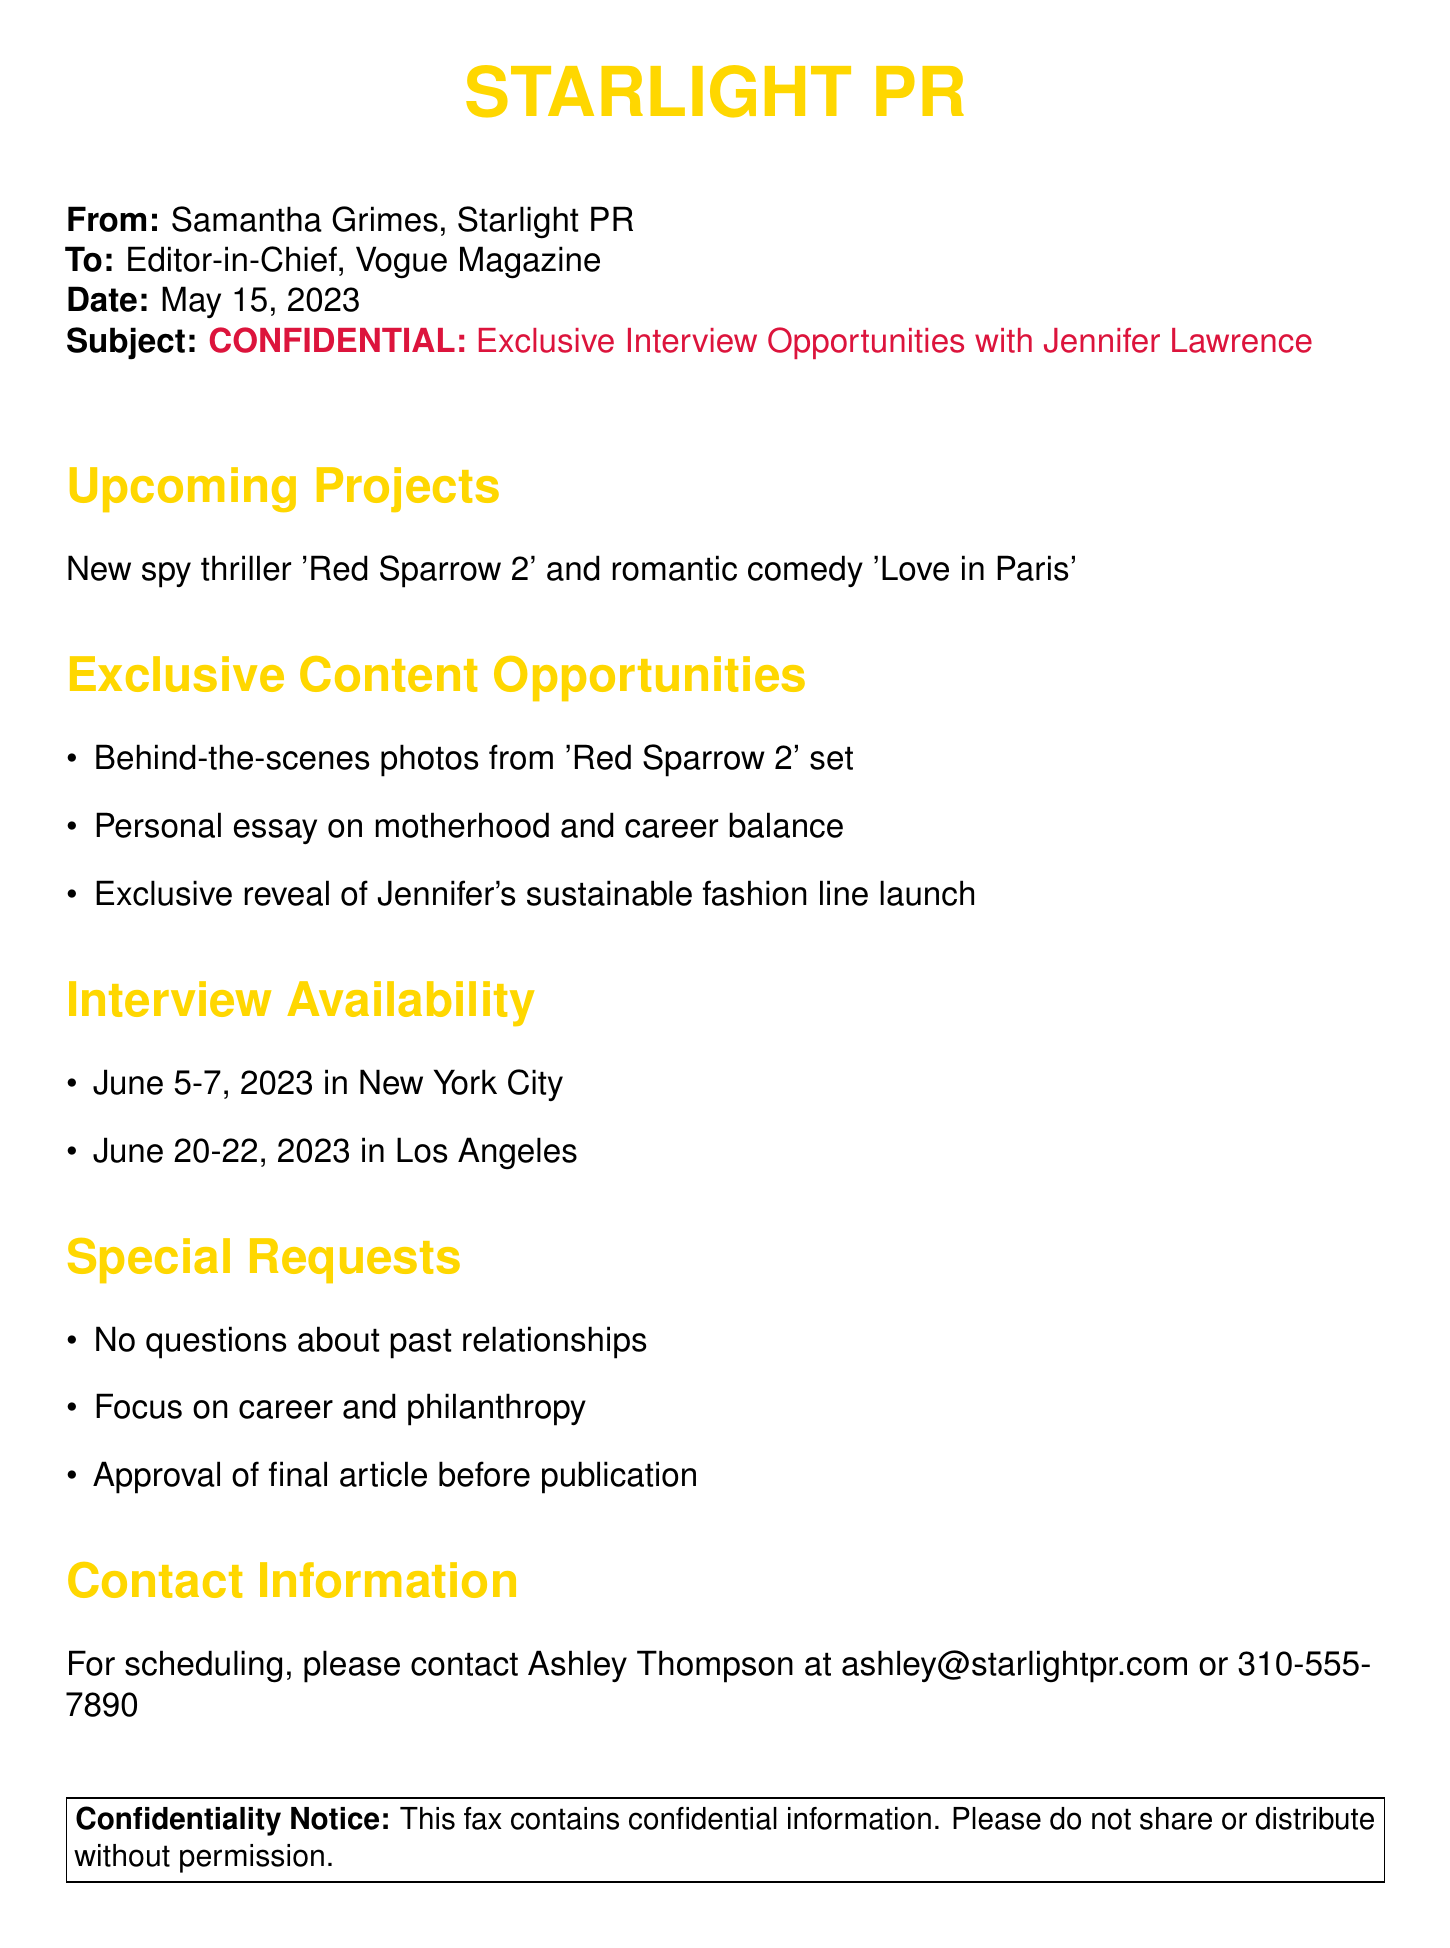What are Jennifer Lawrence's upcoming projects? The document lists the upcoming projects as a new spy thriller 'Red Sparrow 2' and a romantic comedy 'Love in Paris'.
Answer: 'Red Sparrow 2' and 'Love in Paris' When is Jennifer available for interviews in New York City? The document specifies the available dates for interviews in New York City as June 5-7, 2023.
Answer: June 5-7, 2023 What request has been made regarding the content of the interview? The document mentions a special request for the interview to focus on career and philanthropy.
Answer: Focus on career and philanthropy How many projects are mentioned in the 'Upcoming Projects' section? There are two projects listed in that section: 'Red Sparrow 2' and 'Love in Paris'.
Answer: 2 Who should be contacted for scheduling the interview? The document provides Ashley Thompson's contact information for scheduling.
Answer: Ashley Thompson What is the date of the fax? The fax is dated May 15, 2023.
Answer: May 15, 2023 What type of content is Jennifer Lawrence offering that relates to her personal life? The document indicates that she is providing a personal essay on motherhood and career balance.
Answer: Personal essay on motherhood and career balance What is the confidentiality notice about? The confidentiality notice in the document states that it contains confidential information and should not be shared without permission.
Answer: Confidential information 